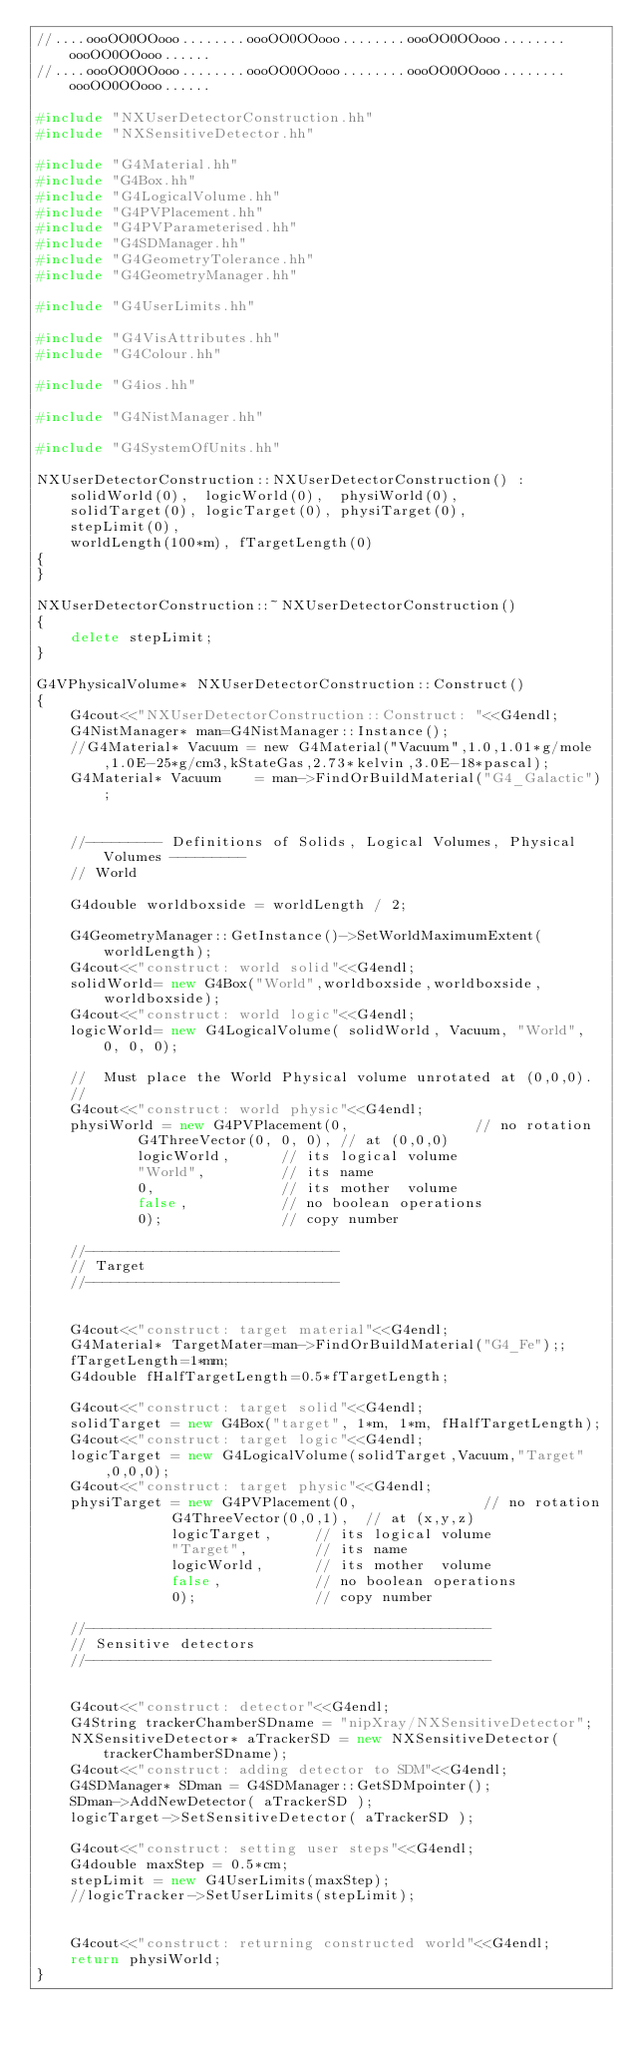<code> <loc_0><loc_0><loc_500><loc_500><_C++_>//....oooOO0OOooo........oooOO0OOooo........oooOO0OOooo........oooOO0OOooo...... 
//....oooOO0OOooo........oooOO0OOooo........oooOO0OOooo........oooOO0OOooo......

#include "NXUserDetectorConstruction.hh"
#include "NXSensitiveDetector.hh"

#include "G4Material.hh"
#include "G4Box.hh"
#include "G4LogicalVolume.hh"
#include "G4PVPlacement.hh"
#include "G4PVParameterised.hh"
#include "G4SDManager.hh"
#include "G4GeometryTolerance.hh"
#include "G4GeometryManager.hh"

#include "G4UserLimits.hh"

#include "G4VisAttributes.hh"
#include "G4Colour.hh"

#include "G4ios.hh"

#include "G4NistManager.hh"

#include "G4SystemOfUnits.hh"

NXUserDetectorConstruction::NXUserDetectorConstruction() :
    solidWorld(0),  logicWorld(0),  physiWorld(0),
    solidTarget(0), logicTarget(0), physiTarget(0), 
    stepLimit(0), 
    worldLength(100*m), fTargetLength(0)
{
}

NXUserDetectorConstruction::~NXUserDetectorConstruction()
{
    delete stepLimit;
}

G4VPhysicalVolume* NXUserDetectorConstruction::Construct()
{
    G4cout<<"NXUserDetectorConstruction::Construct: "<<G4endl;
    G4NistManager* man=G4NistManager::Instance();
    //G4Material* Vacuum = new G4Material("Vacuum",1.0,1.01*g/mole,1.0E-25*g/cm3,kStateGas,2.73*kelvin,3.0E-18*pascal);
    G4Material* Vacuum    = man->FindOrBuildMaterial("G4_Galactic");


    //--------- Definitions of Solids, Logical Volumes, Physical Volumes ---------
    // World

    G4double worldboxside = worldLength / 2;

    G4GeometryManager::GetInstance()->SetWorldMaximumExtent(worldLength);
    G4cout<<"construct: world solid"<<G4endl;
    solidWorld= new G4Box("World",worldboxside,worldboxside,worldboxside);
    G4cout<<"construct: world logic"<<G4endl;
    logicWorld= new G4LogicalVolume( solidWorld, Vacuum, "World", 0, 0, 0);

    //  Must place the World Physical volume unrotated at (0,0,0).
    // 
    G4cout<<"construct: world physic"<<G4endl;
    physiWorld = new G4PVPlacement(0,               // no rotation
            G4ThreeVector(0, 0, 0), // at (0,0,0)
            logicWorld,      // its logical volume
            "World",         // its name
            0,               // its mother  volume
            false,           // no boolean operations
            0);              // copy number

    //------------------------------ 
    // Target
    //------------------------------
 
    
    G4cout<<"construct: target material"<<G4endl;
    G4Material* TargetMater=man->FindOrBuildMaterial("G4_Fe");;
    fTargetLength=1*mm;
    G4double fHalfTargetLength=0.5*fTargetLength;

    G4cout<<"construct: target solid"<<G4endl;
    solidTarget = new G4Box("target", 1*m, 1*m, fHalfTargetLength);
    G4cout<<"construct: target logic"<<G4endl;
    logicTarget = new G4LogicalVolume(solidTarget,Vacuum,"Target",0,0,0);
    G4cout<<"construct: target physic"<<G4endl;
    physiTarget = new G4PVPlacement(0,               // no rotation
                G4ThreeVector(0,0,1),  // at (x,y,z)
                logicTarget,     // its logical volume				  
                "Target",        // its name
                logicWorld,      // its mother  volume
                false,           // no boolean operations
                0);              // copy number 

    //------------------------------------------------ 
    // Sensitive detectors
    //------------------------------------------------ 

    
    G4cout<<"construct: detector"<<G4endl;
    G4String trackerChamberSDname = "nipXray/NXSensitiveDetector";
    NXSensitiveDetector* aTrackerSD = new NXSensitiveDetector(trackerChamberSDname);
    G4cout<<"construct: adding detector to SDM"<<G4endl;
    G4SDManager* SDman = G4SDManager::GetSDMpointer();
    SDman->AddNewDetector( aTrackerSD );
    logicTarget->SetSensitiveDetector( aTrackerSD );
    
    G4cout<<"construct: setting user steps"<<G4endl;
    G4double maxStep = 0.5*cm;
    stepLimit = new G4UserLimits(maxStep);
    //logicTracker->SetUserLimits(stepLimit);
    
    
    G4cout<<"construct: returning constructed world"<<G4endl;
    return physiWorld;
}



</code> 